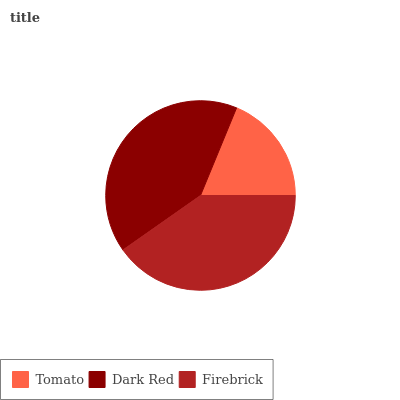Is Tomato the minimum?
Answer yes or no. Yes. Is Dark Red the maximum?
Answer yes or no. Yes. Is Firebrick the minimum?
Answer yes or no. No. Is Firebrick the maximum?
Answer yes or no. No. Is Dark Red greater than Firebrick?
Answer yes or no. Yes. Is Firebrick less than Dark Red?
Answer yes or no. Yes. Is Firebrick greater than Dark Red?
Answer yes or no. No. Is Dark Red less than Firebrick?
Answer yes or no. No. Is Firebrick the high median?
Answer yes or no. Yes. Is Firebrick the low median?
Answer yes or no. Yes. Is Dark Red the high median?
Answer yes or no. No. Is Tomato the low median?
Answer yes or no. No. 